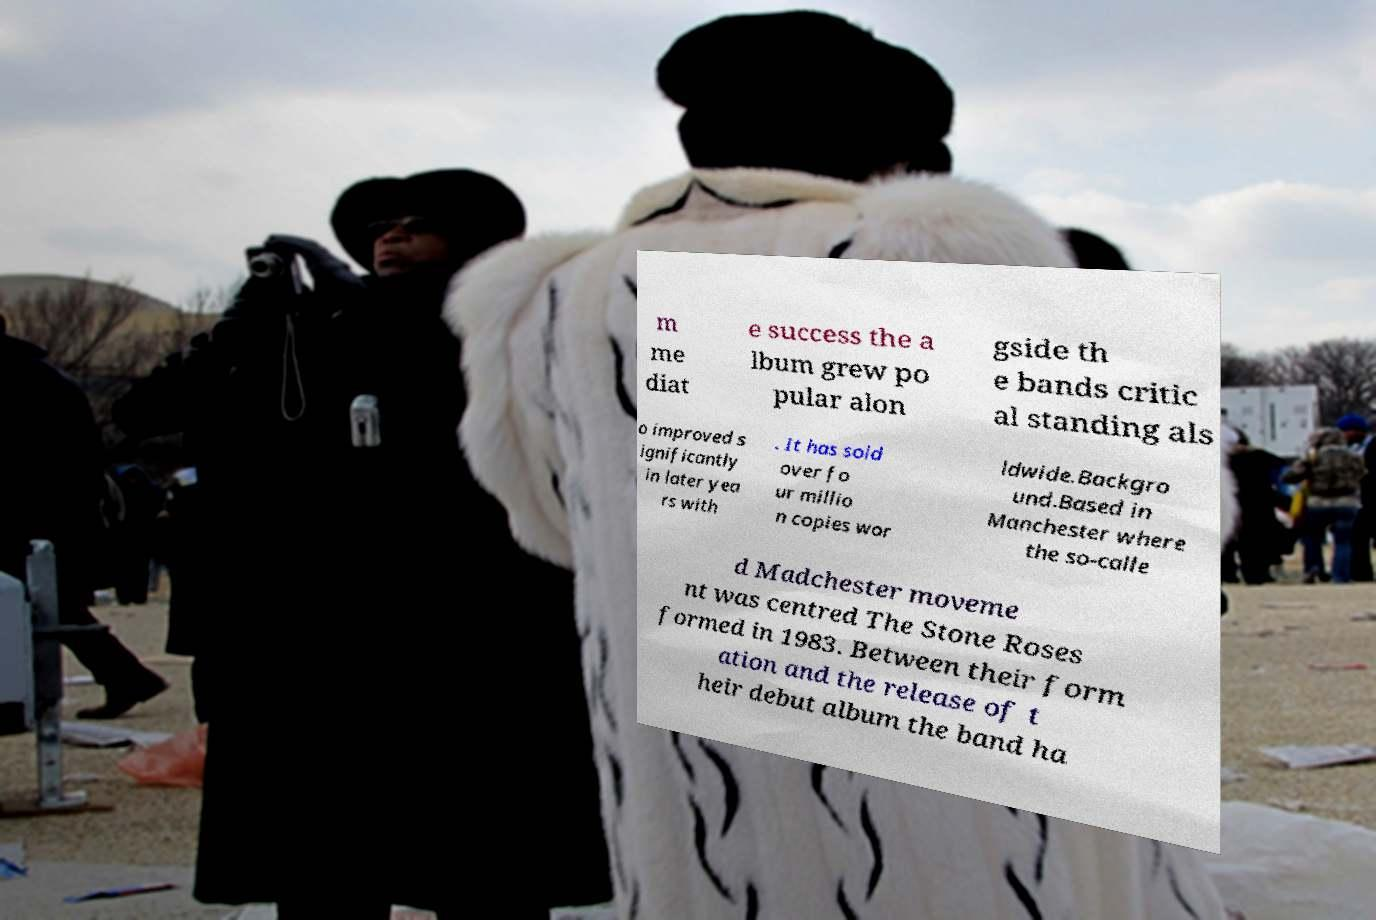Can you read and provide the text displayed in the image?This photo seems to have some interesting text. Can you extract and type it out for me? m me diat e success the a lbum grew po pular alon gside th e bands critic al standing als o improved s ignificantly in later yea rs with . It has sold over fo ur millio n copies wor ldwide.Backgro und.Based in Manchester where the so-calle d Madchester moveme nt was centred The Stone Roses formed in 1983. Between their form ation and the release of t heir debut album the band ha 